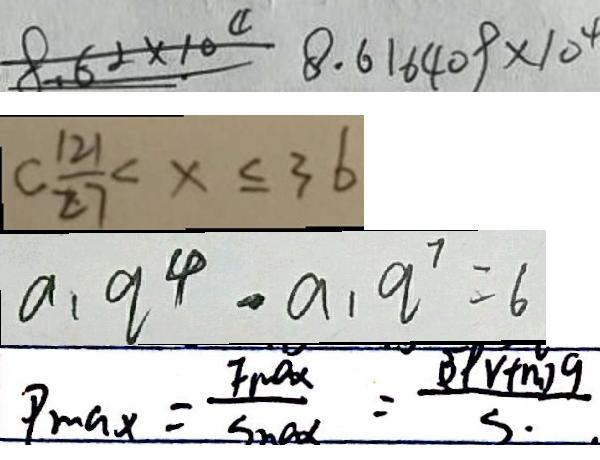Convert formula to latex. <formula><loc_0><loc_0><loc_500><loc_500>8 . 6 2 \times 1 0 ^ { 4 } 8 . 6 1 6 4 0 9 \times 1 0 ^ { 4 } 
 C \frac { 1 2 1 } { 2 7 } < x \leq 3 6 
 a _ { 1 } q ^ { 4 } - a _ { 1 } q ^ { 7 } = 6 
 P _ { \max } = \frac { F _ { \max } + S _ { \max } } { \sin x } = \frac { ( 3 p v + n ) g } { s }</formula> 